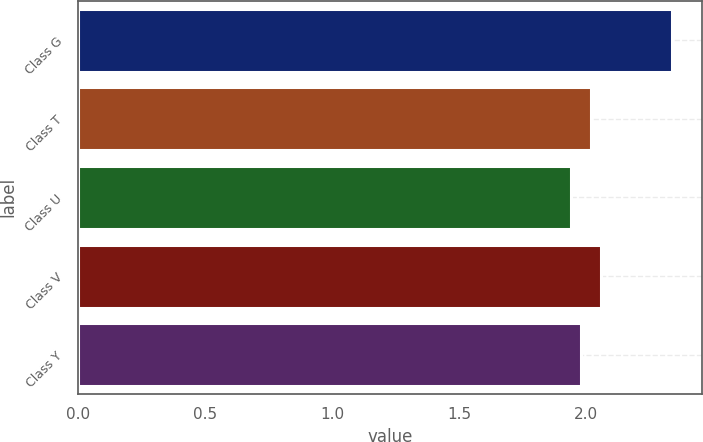<chart> <loc_0><loc_0><loc_500><loc_500><bar_chart><fcel>Class G<fcel>Class T<fcel>Class U<fcel>Class V<fcel>Class Y<nl><fcel>2.34<fcel>2.02<fcel>1.94<fcel>2.06<fcel>1.98<nl></chart> 